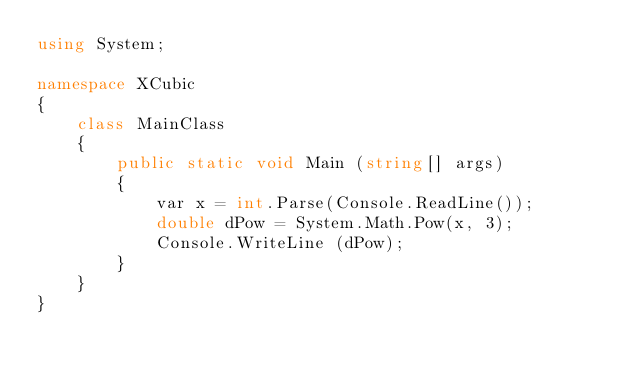<code> <loc_0><loc_0><loc_500><loc_500><_C#_>using System;
 
namespace XCubic
{
    class MainClass
    {
        public static void Main (string[] args)
        {
            var x = int.Parse(Console.ReadLine());
            double dPow = System.Math.Pow(x, 3);
            Console.WriteLine (dPow);
        }
    }
}</code> 